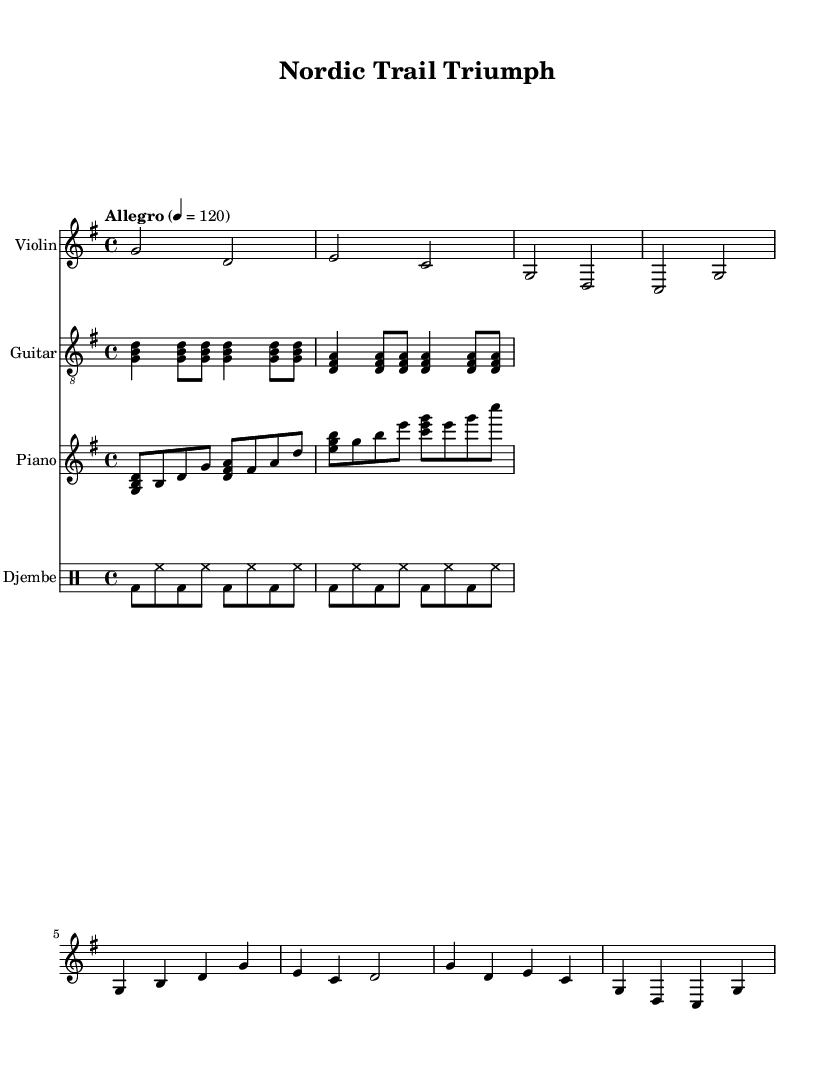What is the key signature of this music? The key signature is G major, which has one sharp (F#). This can be determined by looking at the key signature indicated at the beginning of the score.
Answer: G major What is the time signature of this music? The time signature is 4/4, which is indicated at the beginning of the score. It means there are four beats in each measure, and the quarter note receives one beat.
Answer: 4/4 What is the tempo marking of this music? The tempo marking is "Allegro," which indicates a fast and lively pace. It is paired with a metronome marking of 120 beats per minute, suggesting a brisk tempo.
Answer: Allegro How many measures are in the violin part? The violin part consists of six measures. This is counted by looking at the grouping of the notes and bar lines in the violin staff.
Answer: 6 What rhythmic pattern does the djembe play? The djembe plays a steady eighth note pattern with accents on the bass drum on the first and fifth eighth notes of each measure. This pattern can be analyzed by looking at the rhythmic notation in the djembe staff.
Answer: Eighth notes with accents Which instruments are featured in this score? The score features Violin, Guitar, Piano, and Djembe. Each instrument has its own staff clearly labeled at the beginning of the score.
Answer: Violin, Guitar, Piano, Djembe What is the style of this music score? The style of this music score can be described as upbeat and motivational, suitable for outdoor activities such as workouts and hikes. This is inferred from the energetic tempo and instrumentation choices.
Answer: Upbeat and motivational 